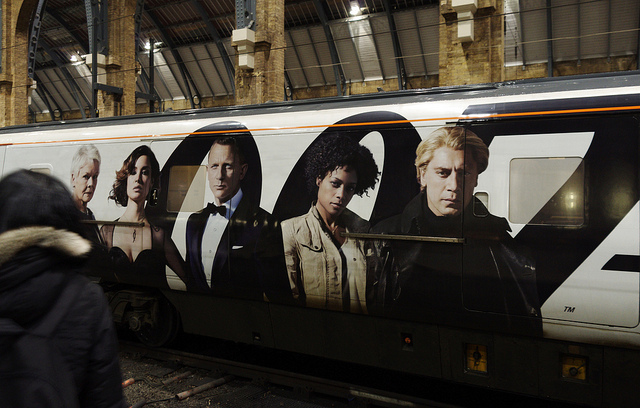<image>Who is the man on the left? I don't know who the man on the left is. It could be Daniel Craig or James Bond. Who is the man on the left? I don't know who the man on the left is. It can be Daniel Craig or James Bond. 